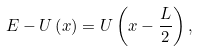<formula> <loc_0><loc_0><loc_500><loc_500>E - U \left ( x \right ) = U \left ( x - \frac { L } { 2 } \right ) ,</formula> 